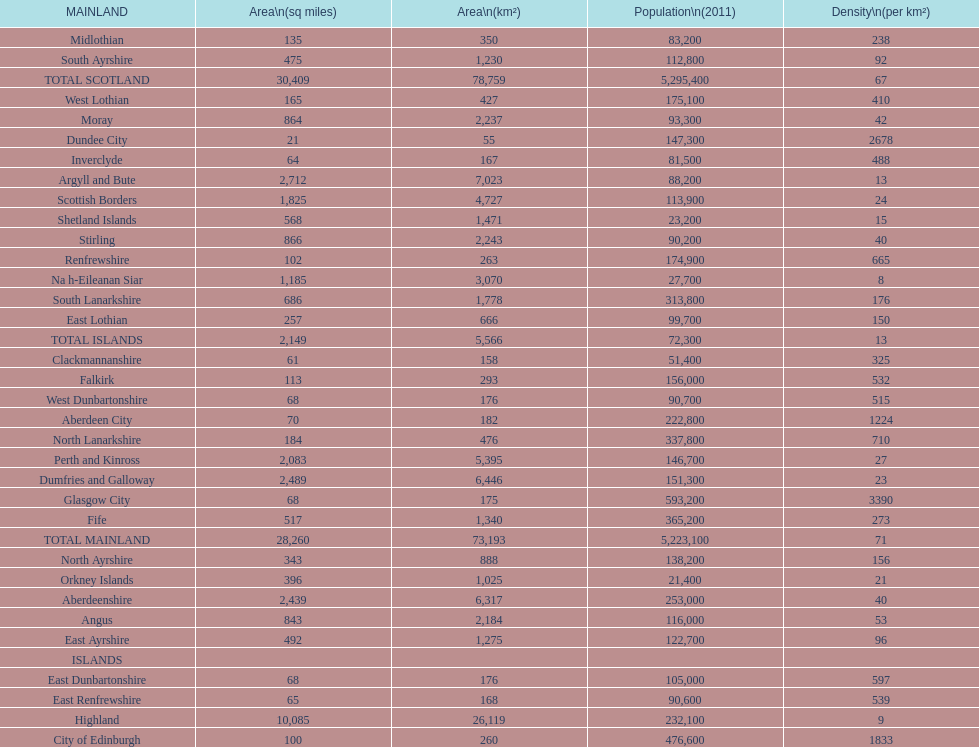What is the number of people living in angus in 2011? 116,000. 